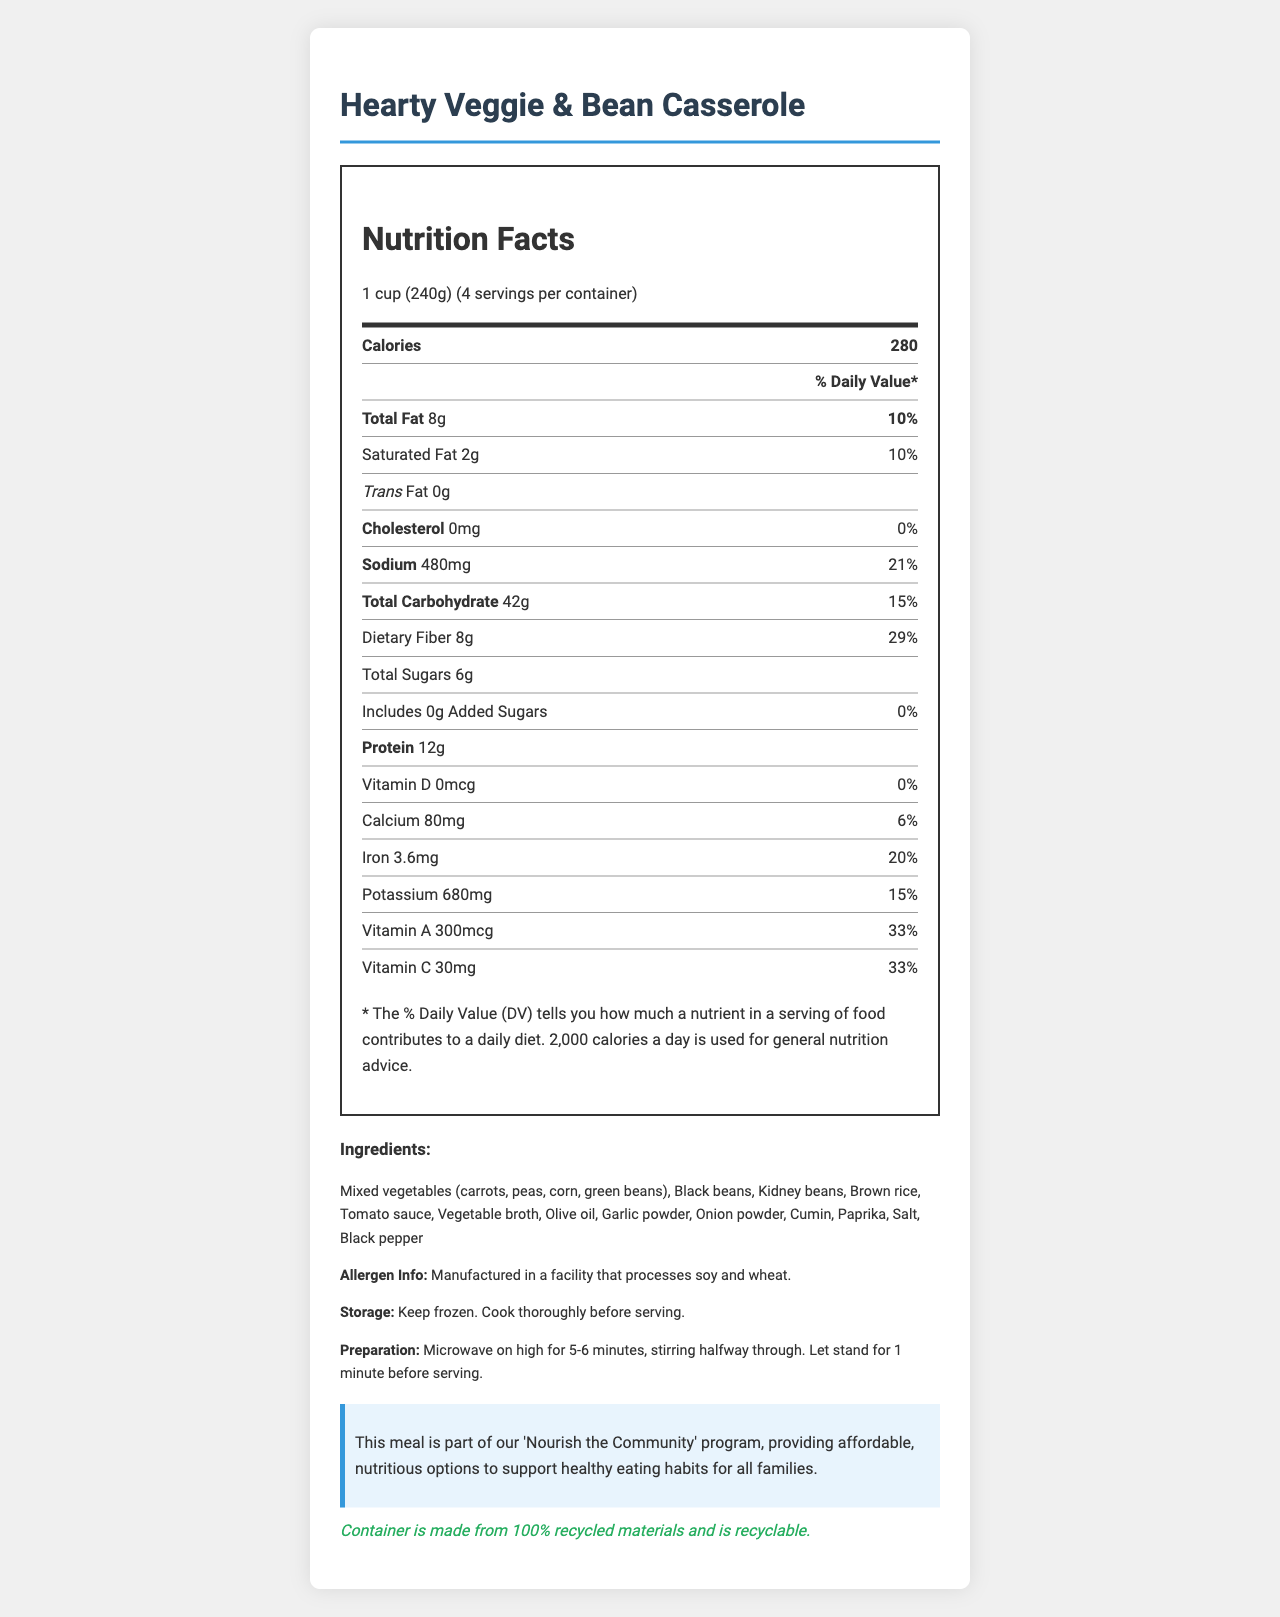what is the serving size of the "Hearty Veggie & Bean Casserole"? The serving size is mentioned at the top of the nutrition facts section: "1 cup (240g)".
Answer: 1 cup (240g) how many servings are in each container? The document states the serving size as "1 cup (240g)" and mentions "4 servings per container".
Answer: 4 how many calories does one serving contain? It is given at the top of the nutrition facts section that one serving contains "280 calories".
Answer: 280 what percentage of the daily value is the sodium content per serving? The sodium content per serving is listed as "480mg" with a percent daily value of "21%".
Answer: 21% what is the total carbohydrate content per serving? The total carbohydrate content per serving is specified as "42g".
Answer: 42g how much dietary fiber is in each serving? The dietary fiber per serving is stated as "8g".
Answer: 8g does the product contain any trans fat? The document states "Trans Fat 0g", indicating there is no trans fat in the product.
Answer: No what are the primary ingredients included in the "Hearty Veggie & Bean Casserole"? The ingredients are listed in the document, starting with mixed vegetables.
Answer: Mixed vegetables (carrots, peas, corn, green beans), Black beans, Kidney beans, Brown rice, Tomato sauce, Vegetable broth, Olive oil, Garlic powder, Onion powder, Cumin, Paprika, Salt, Black pepper which of the following vitamins contributes the most to the daily value?
A. Vitamin D
B. Vitamin A
C. Vitamin C
D. Calcium Vitamin C contributes 33%, Vitamin A contributes 33%, Calcium contributes 6%, and Vitamin D contributes 0%, so Vitamin C and A both contribute most, but Vitamin C is the correct answer as we focus only on one answer per document.
Answer: C how much added sugar does each serving have? The amount of added sugars per serving is specified as "0g".
Answer: 0g what is the percentage of the daily value for iron in each serving? The iron content per serving is listed with a percent daily value of "20%".
Answer: 20% is the product suitable for a low-cholesterol diet? The cholesterol amount is listed as "0mg" which is 0% of the daily value, indicating it is suitable for a low-cholesterol diet.
Answer: Yes what does the social impact statement mention about the product? The document states that the meal is part of a program providing affordable and nutritious options.
Answer: This meal is part of our 'Nourish the Community' program, providing affordable, nutritious options to support healthy eating habits for all families. how long should the "Hearty Veggie & Bean Casserole" be microwaved for preparation? The preparation instructions state to microwave on high for 5-6 minutes.
Answer: 5-6 minutes does this product include a recycling-friendly container? The social impact section specifies that the container is made from 100% recycled materials and is recyclable.
Answer: Yes does the product contain soy allergens? The allergen info states it is manufactured in a facility that processes soy and wheat, but it does not explicitly say the casserole itself contains soy.
Answer: Cannot be determined describe the main idea of the document. The document is a comprehensive overview of the Hearty Veggie & Bean Casserole's nutritional information, ingredients, preparation instructions, and social impact.
Answer: This document provides nutrition facts, ingredients, allergen information, storage, and preparation instructions for the "Hearty Veggie & Bean Casserole." It highlights the nutritional content per serving, emphasizes its role in a community nourishment program, and mentions the recyclability of the container. 